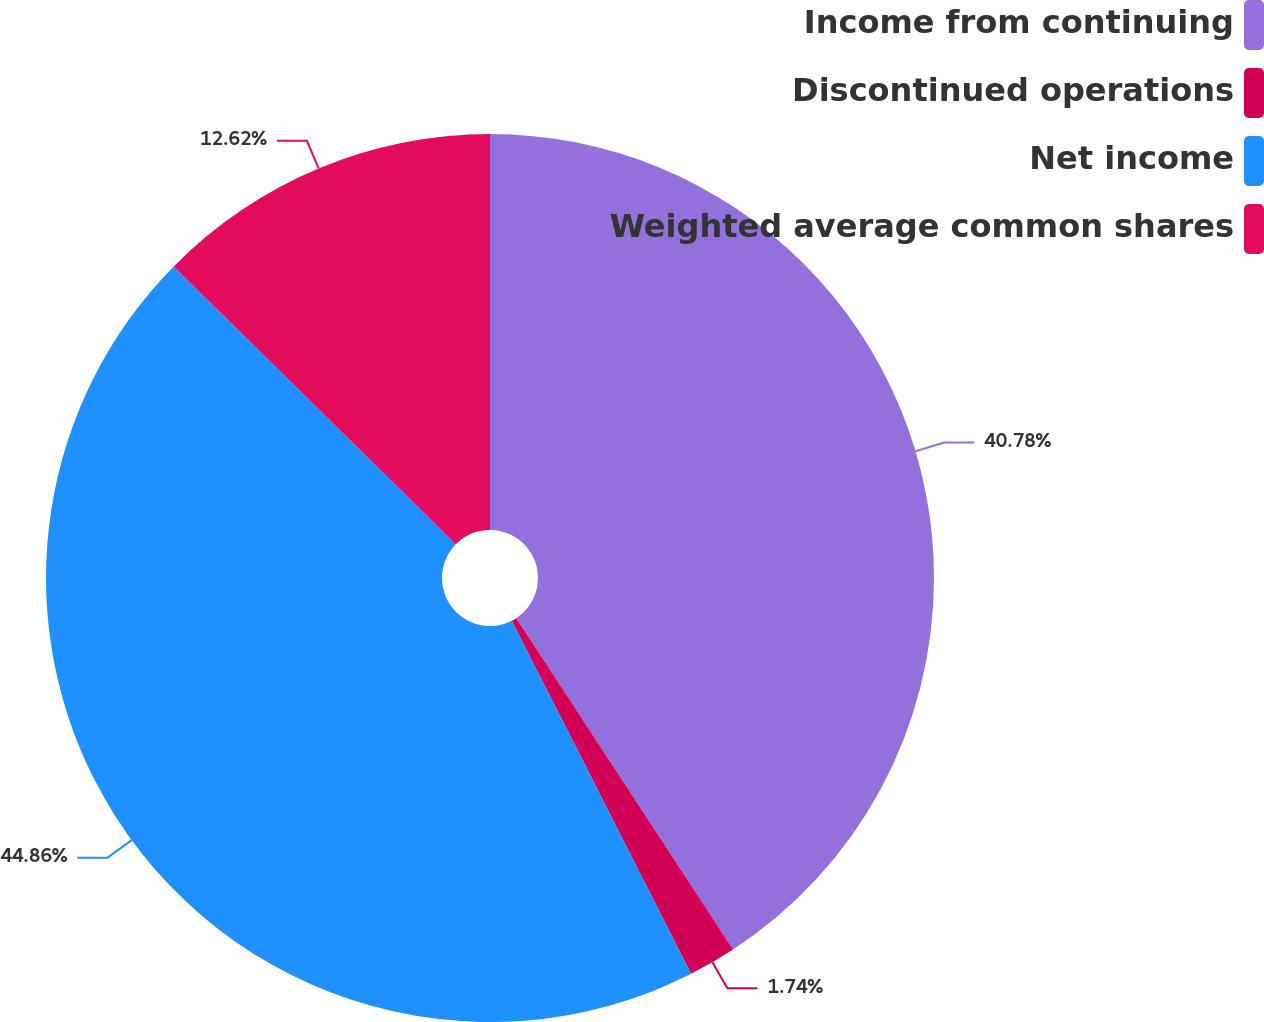Convert chart to OTSL. <chart><loc_0><loc_0><loc_500><loc_500><pie_chart><fcel>Income from continuing<fcel>Discontinued operations<fcel>Net income<fcel>Weighted average common shares<nl><fcel>40.78%<fcel>1.74%<fcel>44.86%<fcel>12.62%<nl></chart> 